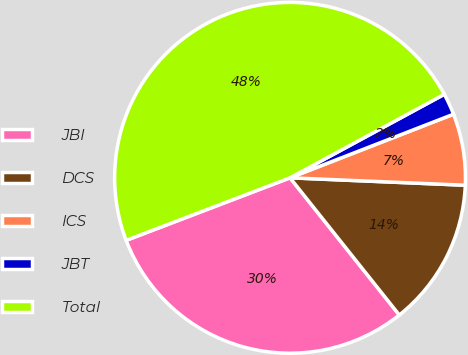Convert chart. <chart><loc_0><loc_0><loc_500><loc_500><pie_chart><fcel>JBI<fcel>DCS<fcel>ICS<fcel>JBT<fcel>Total<nl><fcel>29.9%<fcel>13.62%<fcel>6.58%<fcel>1.99%<fcel>47.9%<nl></chart> 